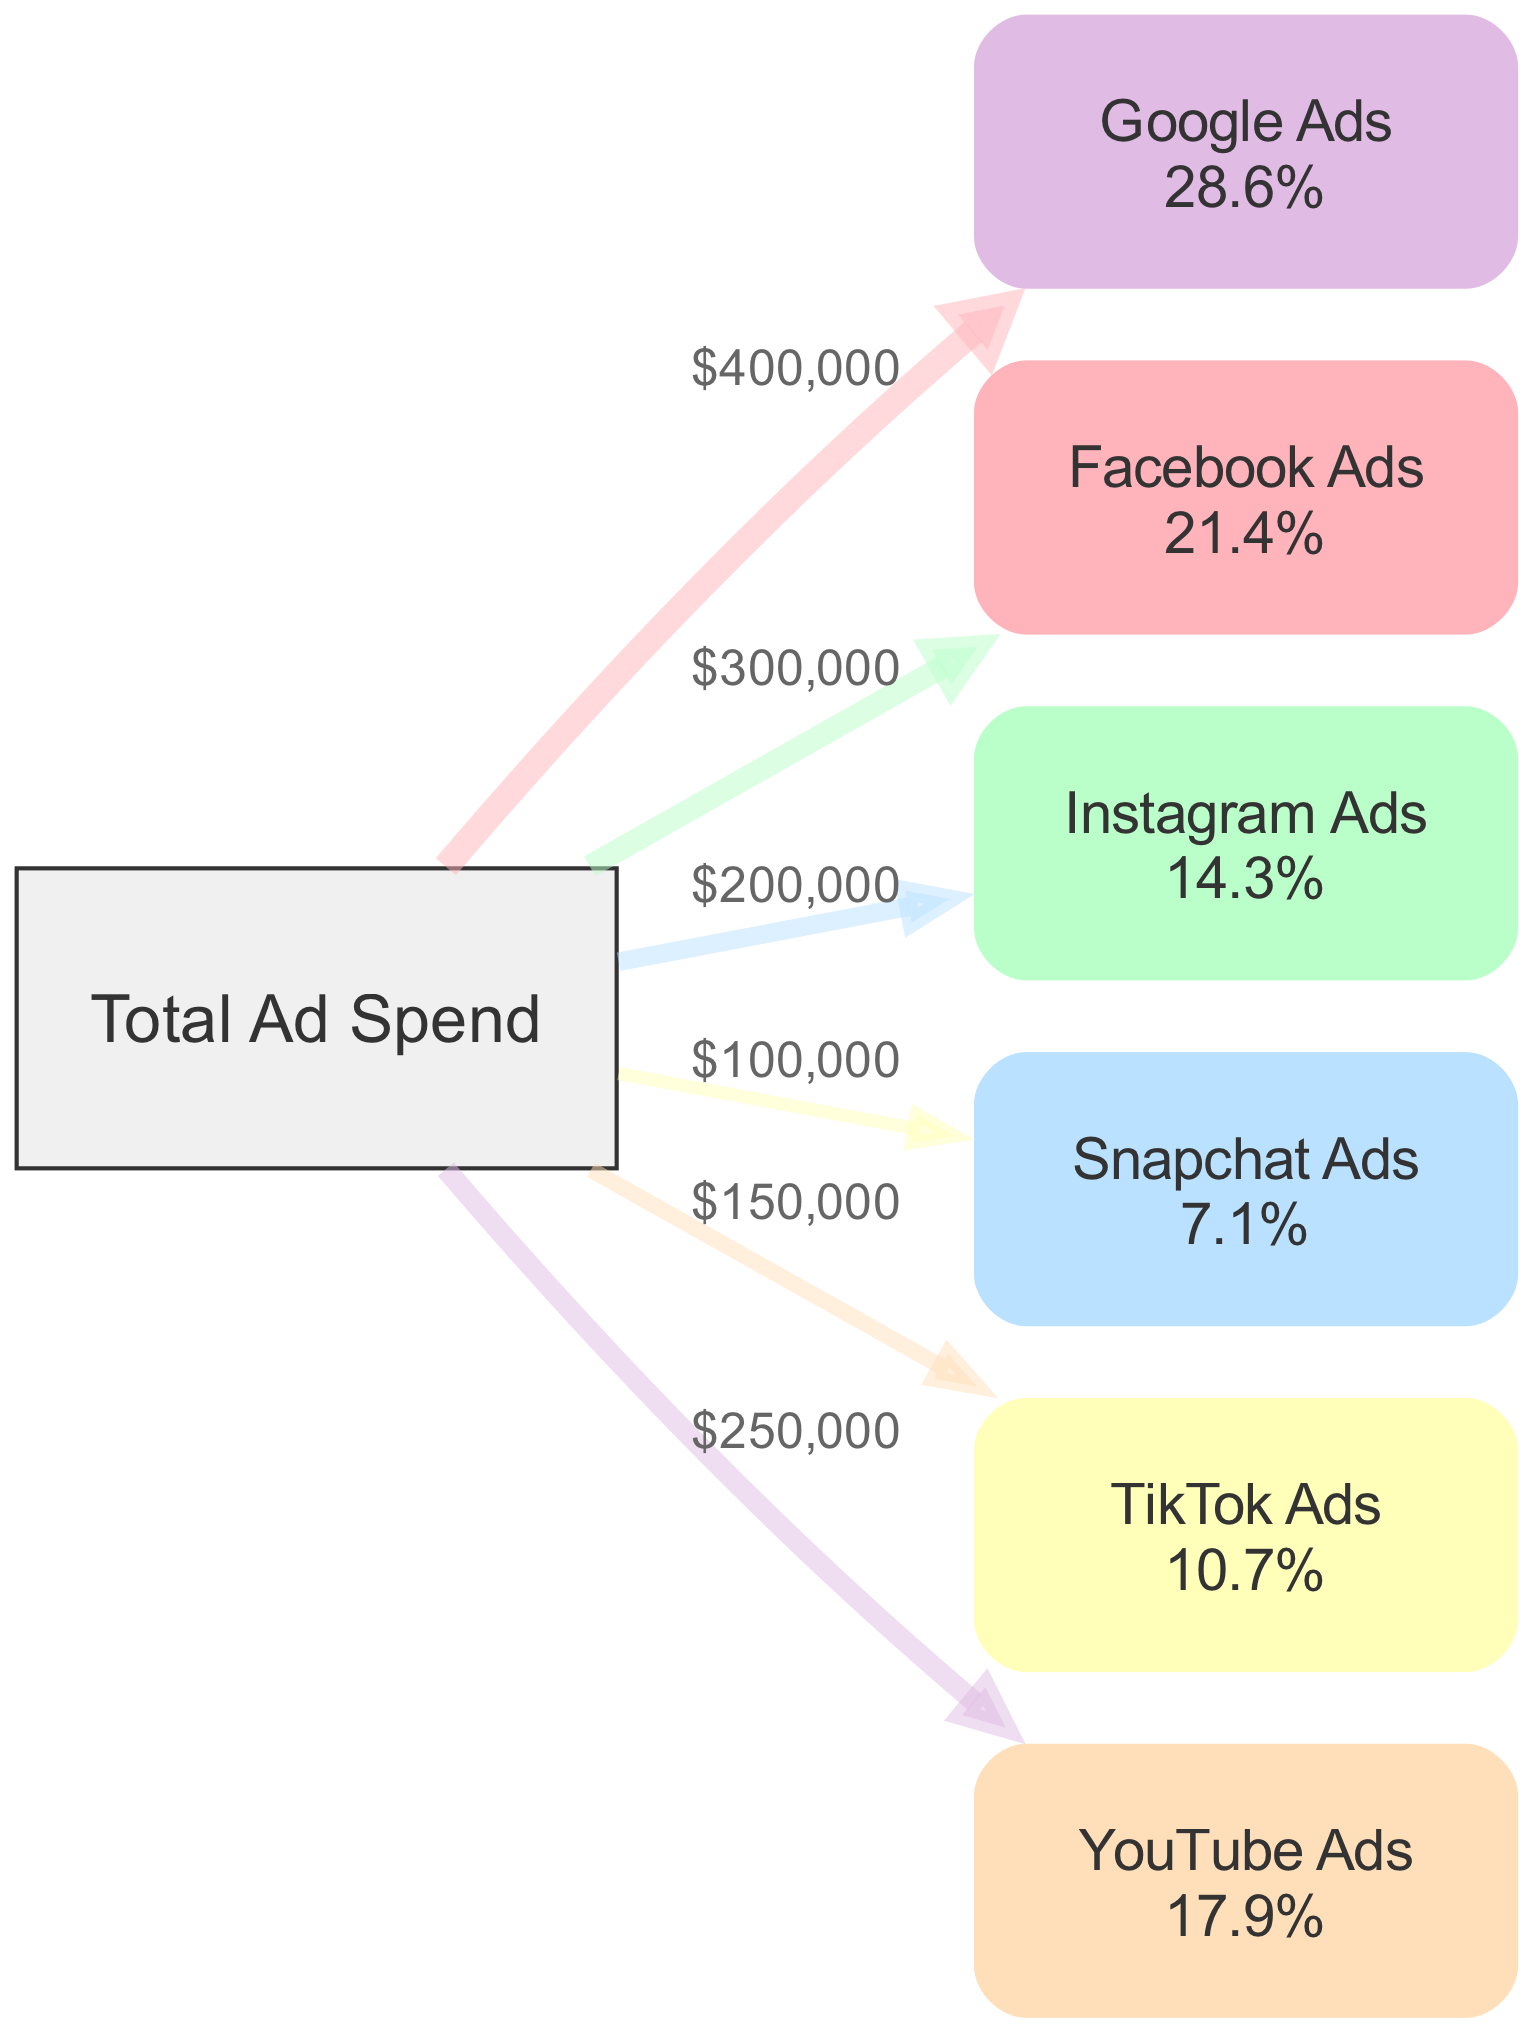What is the total ad spend? By examining the "Total Ad Spend" node, we see that it acts as the source for the various platforms' spends. The summation of the values allocated to each platform indicates that the total ad spend is 1,400,000.
Answer: 1,400,000 Which platform received the highest ad spend? We need to evaluate the values connecting to each platform from the "Total Ad Spend." The values are: Google Ads (400,000), Facebook Ads (300,000), Instagram Ads (200,000), Snapchat Ads (100,000), TikTok Ads (150,000), and YouTube Ads (250,000). The highest value here is 400,000, corresponding to Google Ads.
Answer: Google Ads What percentage of total ad spend was allocated to Instagram Ads? To find this, we look at the link value for Instagram Ads, which is 200,000. We calculate the percentage as (200,000 / 1,400,000) * 100, which gives us approximately 14.3%.
Answer: 14.3% How much less was spent on Snapchat Ads compared to TikTok Ads? First, we identify the spend values: Snapchat Ads received 100,000, while TikTok Ads received 150,000. The difference is calculated as 150,000 - 100,000, resulting in 50,000.
Answer: 50,000 What proportion of Total Ad Spend is attributed to Facebook and YouTube Ads combined? The combined spend for Facebook Ads (300,000) and YouTube Ads (250,000) is 300,000 + 250,000 = 550,000. To find the proportion, we divide by Total Ad Spend: (550,000 / 1,400,000) * 100, yielding approximately 39.3%.
Answer: 39.3% Which two platforms had the lowest ad spends? Reviewing the values for each platform, Snapchat Ads had 100,000 and TikTok Ads had 150,000. Hence, the two platforms with the lowest ad spend are Snapchat Ads and Instagram Ads.
Answer: Snapchat Ads and Instagram Ads What is the difference in ad spend between the second and third largest platforms? The ad spends are as follows: Google Ads (400,000), Facebook Ads (300,000), Instagram Ads (200,000). The difference between Facebook Ads (second largest) and Instagram Ads (third largest) is 300,000 - 200,000, which equals 100,000.
Answer: 100,000 How many mobile ad platforms are represented in this diagram? The nodes list includes six distinct platforms: Google Ads, Facebook Ads, Instagram Ads, Snapchat Ads, TikTok Ads, and YouTube Ads. This gives us a total of six platforms.
Answer: 6 What type of diagram is being used here? The data represents a flow of ad spend allocation across different platforms, which is visually depicted. This structure and purpose indicate that the diagram type is a Sankey Diagram.
Answer: Sankey Diagram 